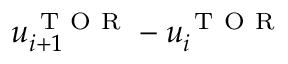<formula> <loc_0><loc_0><loc_500><loc_500>u _ { i + 1 } ^ { T O R } - u _ { i } ^ { T O R }</formula> 